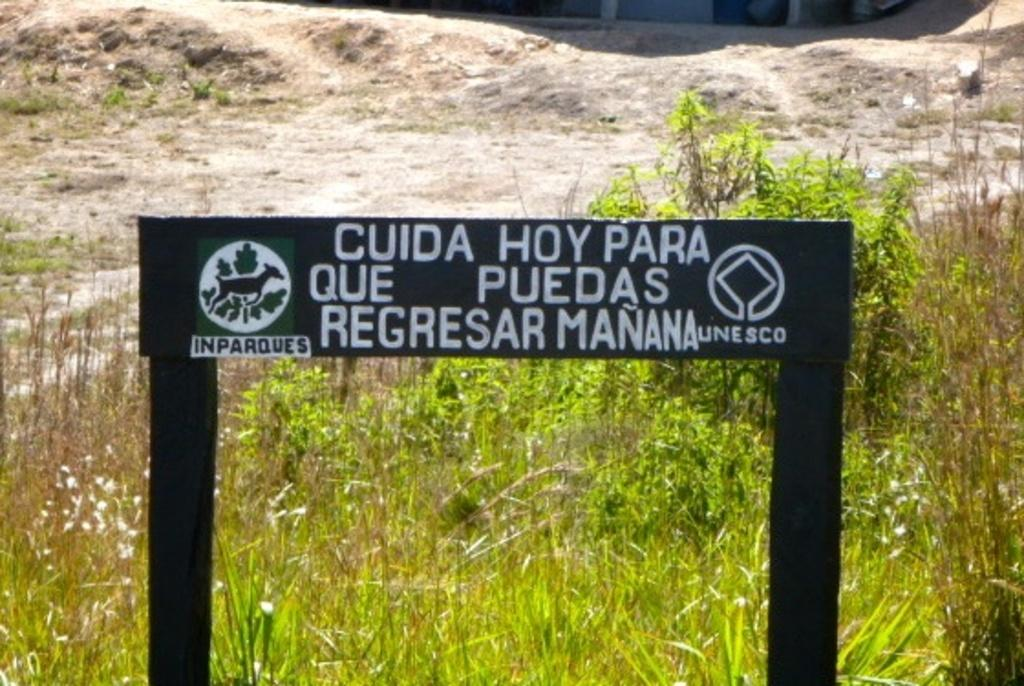What is the main object in the image? There is a black color board in the image. What is on the black color board? Something is written on the black color board. What type of vegetation is visible in the image? There is green grass visible in the image. What is the surface on which the black color board and green grass are placed? There is a ground in the image. Can you tell me how many geese are standing on the black color board in the image? There are no geese present in the image, so it is not possible to determine how many geese might be standing on the black color board. 